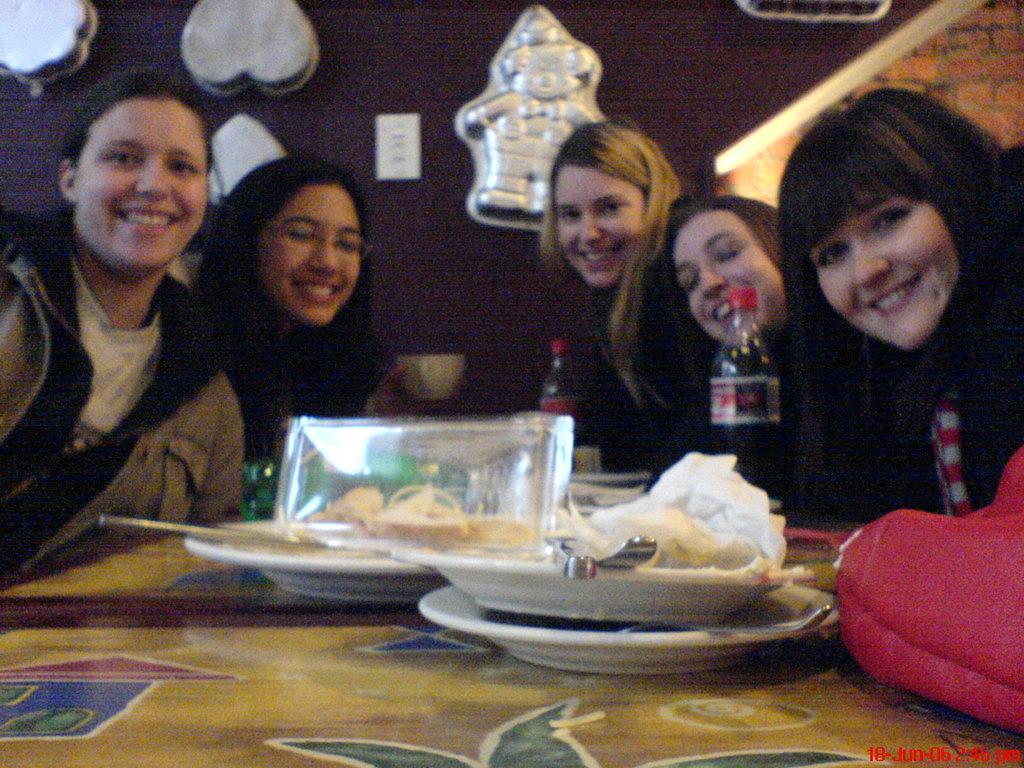Please provide a concise description of this image. This persons are sitting on a chair. In-front of this person there is a table, on table there are plates, spoon and bottle. On wall there are moulds. 